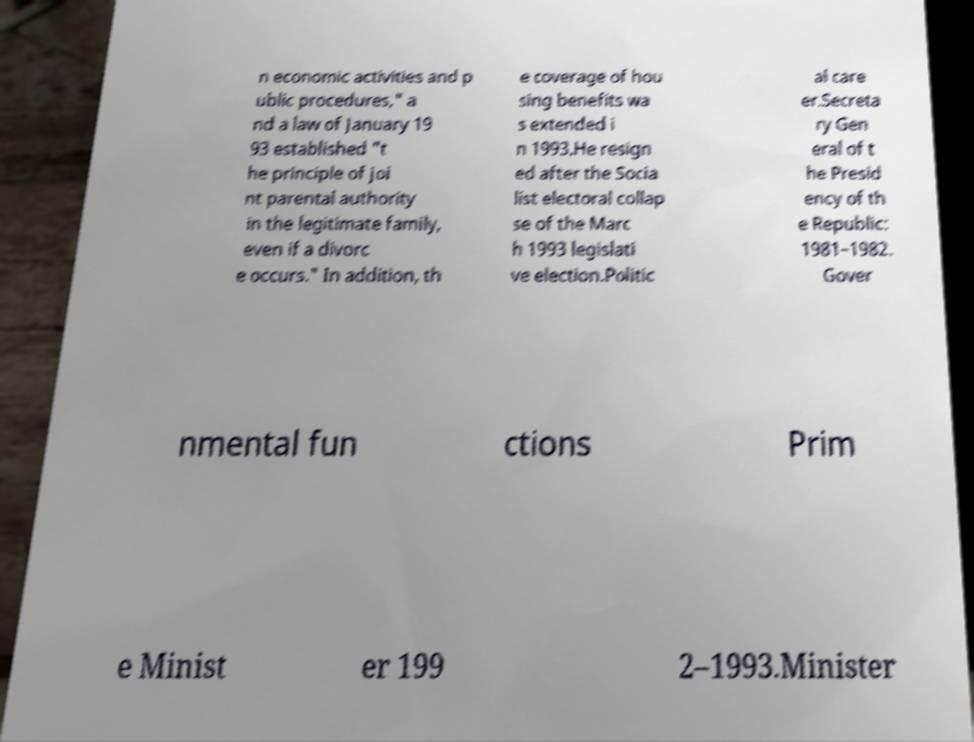What messages or text are displayed in this image? I need them in a readable, typed format. n economic activities and p ublic procedures," a nd a law of January 19 93 established "t he principle of joi nt parental authority in the legitimate family, even if a divorc e occurs." In addition, th e coverage of hou sing benefits wa s extended i n 1993.He resign ed after the Socia list electoral collap se of the Marc h 1993 legislati ve election.Politic al care er.Secreta ry Gen eral of t he Presid ency of th e Republic: 1981–1982. Gover nmental fun ctions Prim e Minist er 199 2–1993.Minister 